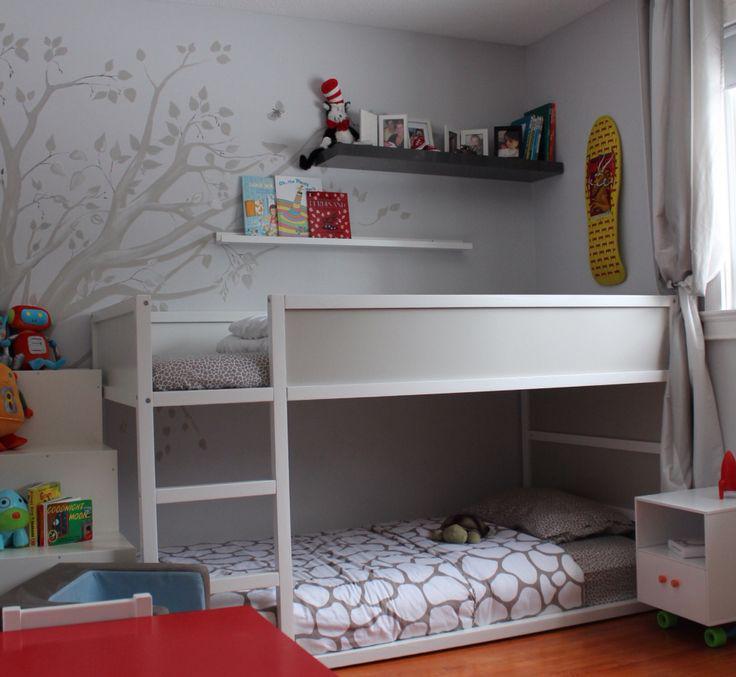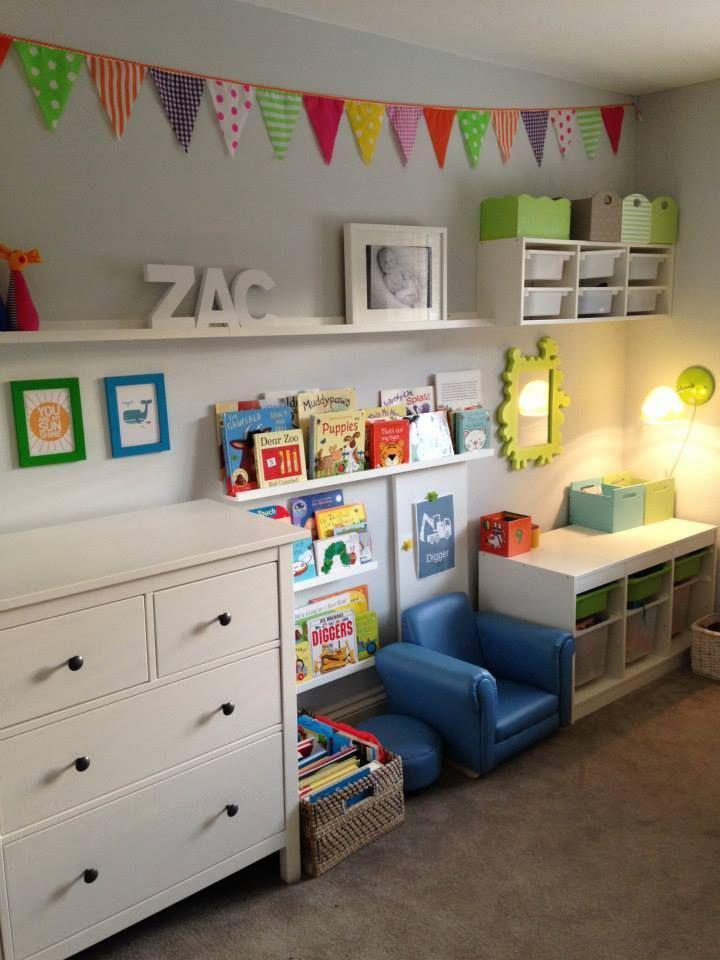The first image is the image on the left, the second image is the image on the right. Evaluate the accuracy of this statement regarding the images: "None of the beds are bunk beds.". Is it true? Answer yes or no. No. The first image is the image on the left, the second image is the image on the right. For the images displayed, is the sentence "AN image shows a bed with a patterned bedspread, flanked by black shelving joined by a top bridge." factually correct? Answer yes or no. No. 